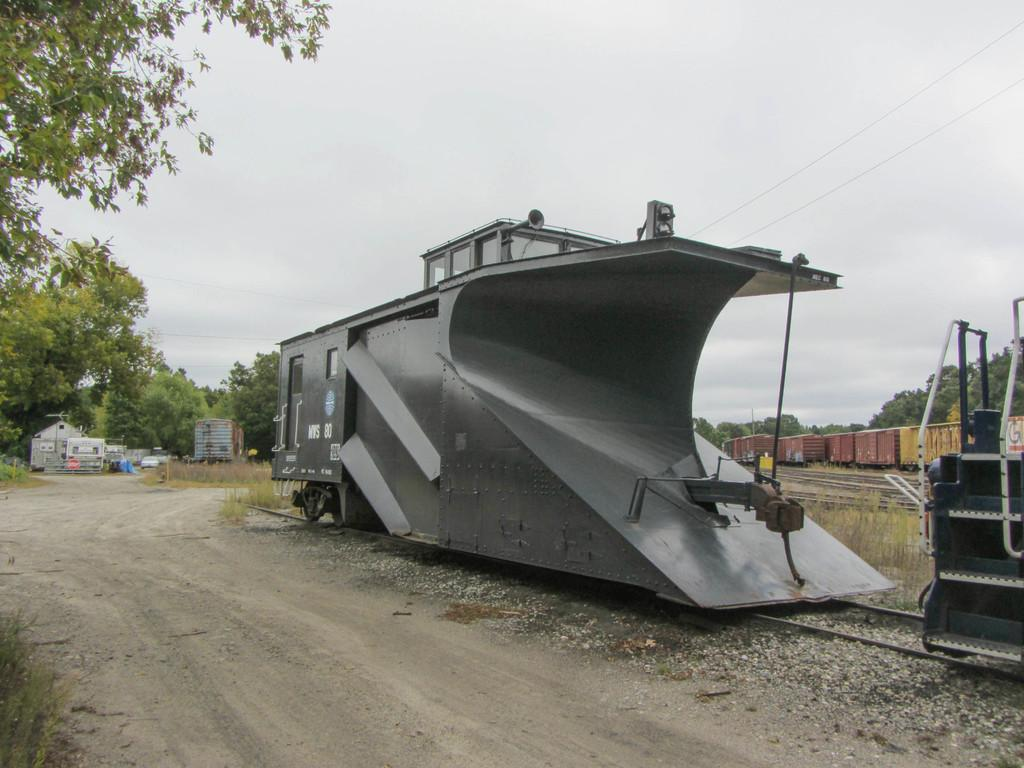What type of transportation can be seen in the image? There are trains on railway tracks in the image. How are the trains positioned in the image? The railway tracks are on the ground, and the trains are on the tracks. What other types of vehicles are present in the image? There are vehicles in the image, but their specific types are not mentioned. What structures can be seen in the image? There are sheds in the image. What type of natural environment is visible in the image? There are trees in the image, and the sky is visible in the background. Can you see any chickens attacking the trains in the image? No, there are no chickens or attacks present in the image. 